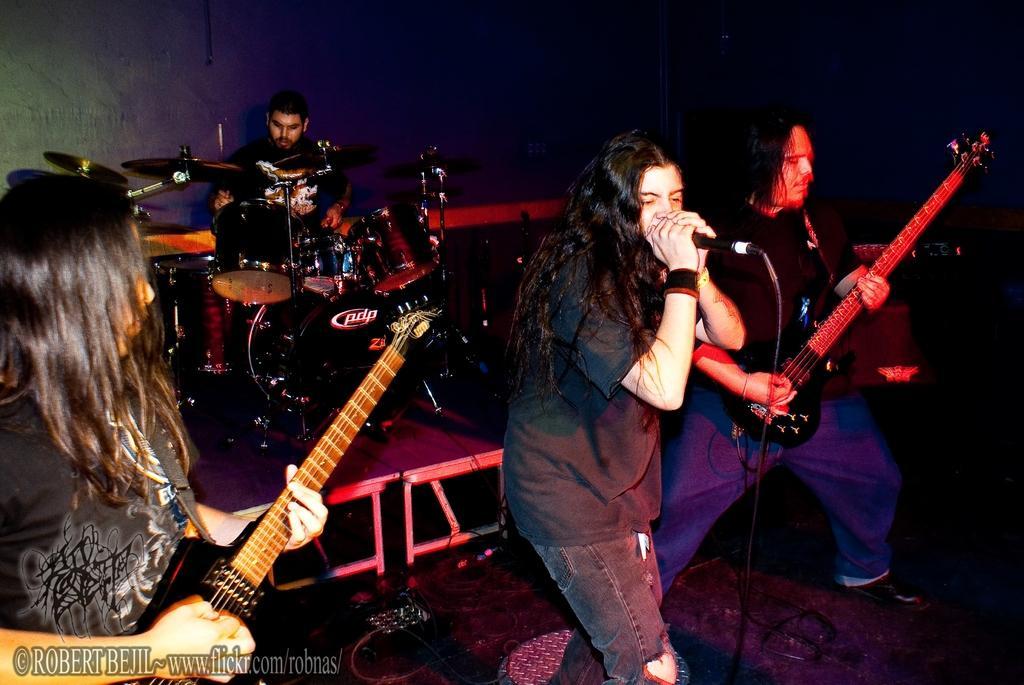Can you describe this image briefly? In this image I can see number of persons are standing on the stage and few of them are holding musical instrument in their hands and a person is holding a microphone. In the background I can see few musical instruments, a person behind them and the dark background. 